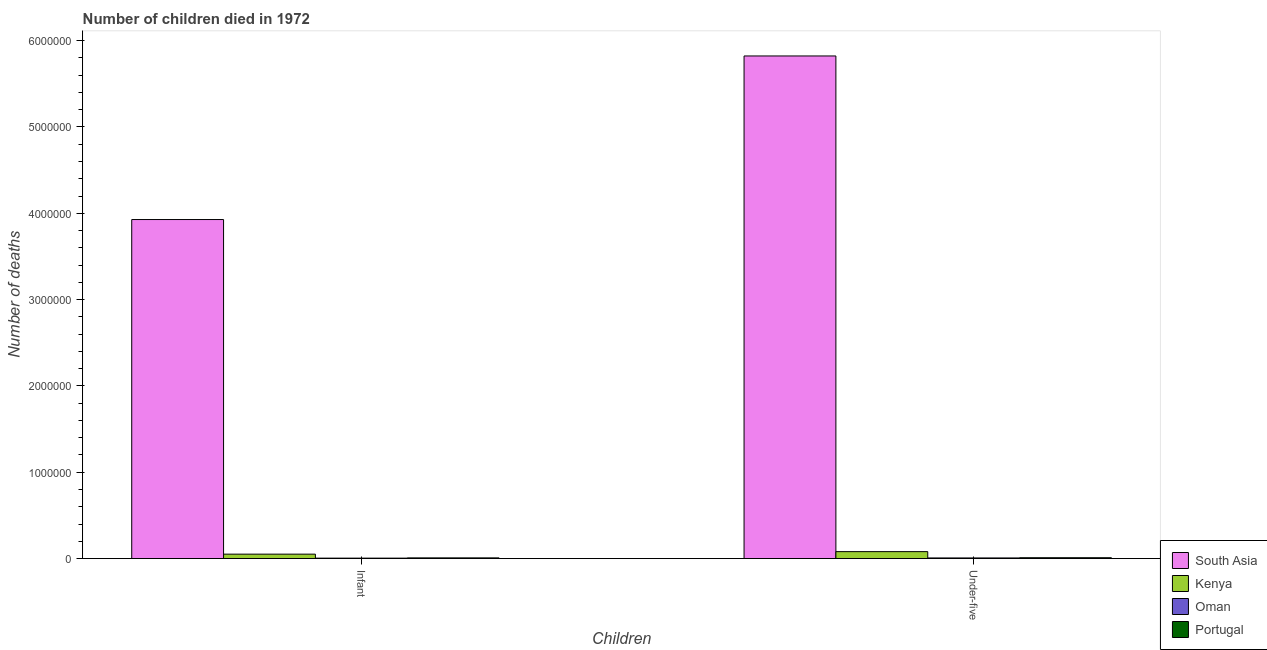Are the number of bars on each tick of the X-axis equal?
Provide a short and direct response. Yes. What is the label of the 1st group of bars from the left?
Offer a very short reply. Infant. What is the number of infant deaths in Kenya?
Your response must be concise. 5.11e+04. Across all countries, what is the maximum number of infant deaths?
Make the answer very short. 3.93e+06. Across all countries, what is the minimum number of under-five deaths?
Your response must be concise. 7278. In which country was the number of infant deaths maximum?
Your answer should be compact. South Asia. In which country was the number of infant deaths minimum?
Ensure brevity in your answer.  Oman. What is the total number of under-five deaths in the graph?
Offer a very short reply. 5.92e+06. What is the difference between the number of under-five deaths in Portugal and that in Kenya?
Give a very brief answer. -7.07e+04. What is the difference between the number of under-five deaths in South Asia and the number of infant deaths in Portugal?
Offer a very short reply. 5.81e+06. What is the average number of infant deaths per country?
Your answer should be compact. 9.98e+05. What is the difference between the number of under-five deaths and number of infant deaths in Oman?
Provide a short and direct response. 2306. In how many countries, is the number of under-five deaths greater than 5000000 ?
Provide a succinct answer. 1. What is the ratio of the number of infant deaths in South Asia to that in Oman?
Ensure brevity in your answer.  789.9. In how many countries, is the number of under-five deaths greater than the average number of under-five deaths taken over all countries?
Offer a terse response. 1. What does the 1st bar from the right in Under-five represents?
Ensure brevity in your answer.  Portugal. How many countries are there in the graph?
Your answer should be very brief. 4. Where does the legend appear in the graph?
Your answer should be compact. Bottom right. How many legend labels are there?
Your response must be concise. 4. How are the legend labels stacked?
Give a very brief answer. Vertical. What is the title of the graph?
Give a very brief answer. Number of children died in 1972. What is the label or title of the X-axis?
Make the answer very short. Children. What is the label or title of the Y-axis?
Make the answer very short. Number of deaths. What is the Number of deaths in South Asia in Infant?
Offer a very short reply. 3.93e+06. What is the Number of deaths in Kenya in Infant?
Your answer should be compact. 5.11e+04. What is the Number of deaths of Oman in Infant?
Provide a succinct answer. 4972. What is the Number of deaths of Portugal in Infant?
Give a very brief answer. 7937. What is the Number of deaths in South Asia in Under-five?
Give a very brief answer. 5.82e+06. What is the Number of deaths of Kenya in Under-five?
Provide a succinct answer. 8.04e+04. What is the Number of deaths of Oman in Under-five?
Offer a very short reply. 7278. What is the Number of deaths in Portugal in Under-five?
Your response must be concise. 9709. Across all Children, what is the maximum Number of deaths in South Asia?
Your answer should be compact. 5.82e+06. Across all Children, what is the maximum Number of deaths of Kenya?
Provide a short and direct response. 8.04e+04. Across all Children, what is the maximum Number of deaths of Oman?
Your response must be concise. 7278. Across all Children, what is the maximum Number of deaths of Portugal?
Provide a short and direct response. 9709. Across all Children, what is the minimum Number of deaths in South Asia?
Offer a terse response. 3.93e+06. Across all Children, what is the minimum Number of deaths of Kenya?
Offer a terse response. 5.11e+04. Across all Children, what is the minimum Number of deaths in Oman?
Your response must be concise. 4972. Across all Children, what is the minimum Number of deaths of Portugal?
Provide a short and direct response. 7937. What is the total Number of deaths of South Asia in the graph?
Give a very brief answer. 9.75e+06. What is the total Number of deaths in Kenya in the graph?
Make the answer very short. 1.32e+05. What is the total Number of deaths of Oman in the graph?
Your answer should be very brief. 1.22e+04. What is the total Number of deaths in Portugal in the graph?
Offer a very short reply. 1.76e+04. What is the difference between the Number of deaths of South Asia in Infant and that in Under-five?
Offer a very short reply. -1.89e+06. What is the difference between the Number of deaths in Kenya in Infant and that in Under-five?
Keep it short and to the point. -2.93e+04. What is the difference between the Number of deaths in Oman in Infant and that in Under-five?
Provide a succinct answer. -2306. What is the difference between the Number of deaths in Portugal in Infant and that in Under-five?
Your response must be concise. -1772. What is the difference between the Number of deaths in South Asia in Infant and the Number of deaths in Kenya in Under-five?
Provide a short and direct response. 3.85e+06. What is the difference between the Number of deaths of South Asia in Infant and the Number of deaths of Oman in Under-five?
Offer a terse response. 3.92e+06. What is the difference between the Number of deaths of South Asia in Infant and the Number of deaths of Portugal in Under-five?
Make the answer very short. 3.92e+06. What is the difference between the Number of deaths of Kenya in Infant and the Number of deaths of Oman in Under-five?
Ensure brevity in your answer.  4.38e+04. What is the difference between the Number of deaths of Kenya in Infant and the Number of deaths of Portugal in Under-five?
Offer a very short reply. 4.14e+04. What is the difference between the Number of deaths in Oman in Infant and the Number of deaths in Portugal in Under-five?
Offer a terse response. -4737. What is the average Number of deaths in South Asia per Children?
Keep it short and to the point. 4.87e+06. What is the average Number of deaths of Kenya per Children?
Give a very brief answer. 6.58e+04. What is the average Number of deaths of Oman per Children?
Provide a succinct answer. 6125. What is the average Number of deaths of Portugal per Children?
Your response must be concise. 8823. What is the difference between the Number of deaths in South Asia and Number of deaths in Kenya in Infant?
Ensure brevity in your answer.  3.88e+06. What is the difference between the Number of deaths in South Asia and Number of deaths in Oman in Infant?
Offer a very short reply. 3.92e+06. What is the difference between the Number of deaths of South Asia and Number of deaths of Portugal in Infant?
Keep it short and to the point. 3.92e+06. What is the difference between the Number of deaths in Kenya and Number of deaths in Oman in Infant?
Give a very brief answer. 4.61e+04. What is the difference between the Number of deaths in Kenya and Number of deaths in Portugal in Infant?
Your answer should be very brief. 4.32e+04. What is the difference between the Number of deaths of Oman and Number of deaths of Portugal in Infant?
Ensure brevity in your answer.  -2965. What is the difference between the Number of deaths in South Asia and Number of deaths in Kenya in Under-five?
Keep it short and to the point. 5.74e+06. What is the difference between the Number of deaths in South Asia and Number of deaths in Oman in Under-five?
Your response must be concise. 5.82e+06. What is the difference between the Number of deaths of South Asia and Number of deaths of Portugal in Under-five?
Your answer should be compact. 5.81e+06. What is the difference between the Number of deaths in Kenya and Number of deaths in Oman in Under-five?
Keep it short and to the point. 7.32e+04. What is the difference between the Number of deaths in Kenya and Number of deaths in Portugal in Under-five?
Your answer should be compact. 7.07e+04. What is the difference between the Number of deaths of Oman and Number of deaths of Portugal in Under-five?
Your answer should be very brief. -2431. What is the ratio of the Number of deaths in South Asia in Infant to that in Under-five?
Ensure brevity in your answer.  0.67. What is the ratio of the Number of deaths in Kenya in Infant to that in Under-five?
Ensure brevity in your answer.  0.64. What is the ratio of the Number of deaths in Oman in Infant to that in Under-five?
Ensure brevity in your answer.  0.68. What is the ratio of the Number of deaths in Portugal in Infant to that in Under-five?
Offer a very short reply. 0.82. What is the difference between the highest and the second highest Number of deaths of South Asia?
Provide a succinct answer. 1.89e+06. What is the difference between the highest and the second highest Number of deaths in Kenya?
Offer a terse response. 2.93e+04. What is the difference between the highest and the second highest Number of deaths in Oman?
Give a very brief answer. 2306. What is the difference between the highest and the second highest Number of deaths of Portugal?
Make the answer very short. 1772. What is the difference between the highest and the lowest Number of deaths in South Asia?
Your response must be concise. 1.89e+06. What is the difference between the highest and the lowest Number of deaths of Kenya?
Provide a short and direct response. 2.93e+04. What is the difference between the highest and the lowest Number of deaths in Oman?
Provide a short and direct response. 2306. What is the difference between the highest and the lowest Number of deaths in Portugal?
Provide a short and direct response. 1772. 